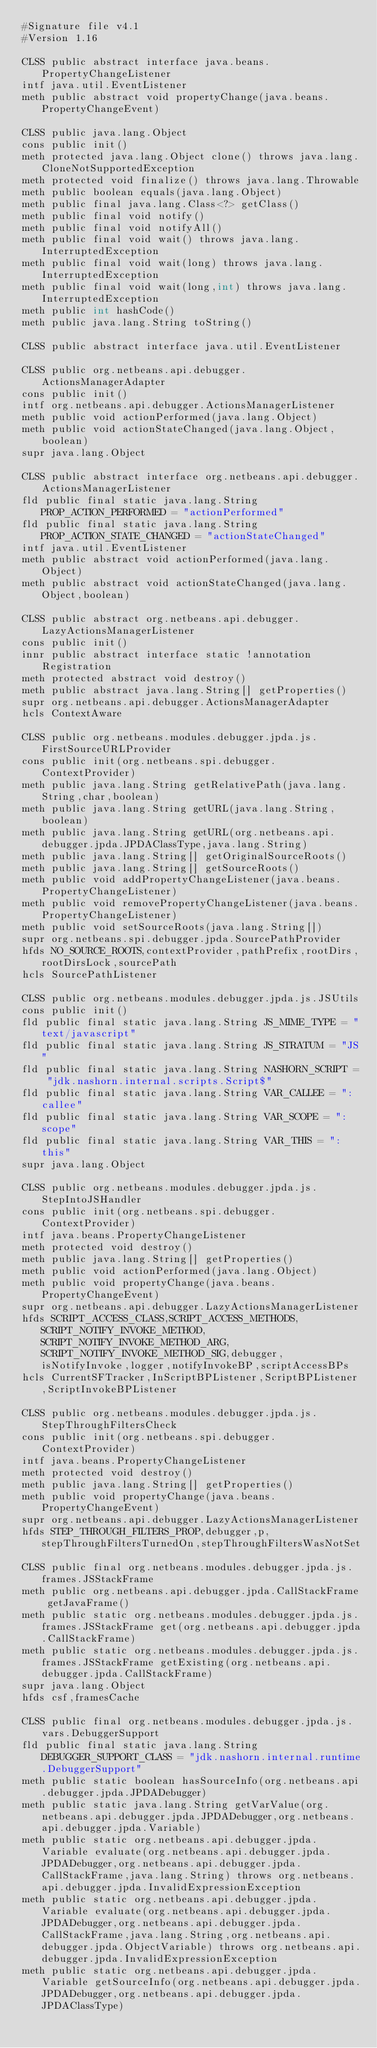<code> <loc_0><loc_0><loc_500><loc_500><_SML_>#Signature file v4.1
#Version 1.16

CLSS public abstract interface java.beans.PropertyChangeListener
intf java.util.EventListener
meth public abstract void propertyChange(java.beans.PropertyChangeEvent)

CLSS public java.lang.Object
cons public init()
meth protected java.lang.Object clone() throws java.lang.CloneNotSupportedException
meth protected void finalize() throws java.lang.Throwable
meth public boolean equals(java.lang.Object)
meth public final java.lang.Class<?> getClass()
meth public final void notify()
meth public final void notifyAll()
meth public final void wait() throws java.lang.InterruptedException
meth public final void wait(long) throws java.lang.InterruptedException
meth public final void wait(long,int) throws java.lang.InterruptedException
meth public int hashCode()
meth public java.lang.String toString()

CLSS public abstract interface java.util.EventListener

CLSS public org.netbeans.api.debugger.ActionsManagerAdapter
cons public init()
intf org.netbeans.api.debugger.ActionsManagerListener
meth public void actionPerformed(java.lang.Object)
meth public void actionStateChanged(java.lang.Object,boolean)
supr java.lang.Object

CLSS public abstract interface org.netbeans.api.debugger.ActionsManagerListener
fld public final static java.lang.String PROP_ACTION_PERFORMED = "actionPerformed"
fld public final static java.lang.String PROP_ACTION_STATE_CHANGED = "actionStateChanged"
intf java.util.EventListener
meth public abstract void actionPerformed(java.lang.Object)
meth public abstract void actionStateChanged(java.lang.Object,boolean)

CLSS public abstract org.netbeans.api.debugger.LazyActionsManagerListener
cons public init()
innr public abstract interface static !annotation Registration
meth protected abstract void destroy()
meth public abstract java.lang.String[] getProperties()
supr org.netbeans.api.debugger.ActionsManagerAdapter
hcls ContextAware

CLSS public org.netbeans.modules.debugger.jpda.js.FirstSourceURLProvider
cons public init(org.netbeans.spi.debugger.ContextProvider)
meth public java.lang.String getRelativePath(java.lang.String,char,boolean)
meth public java.lang.String getURL(java.lang.String,boolean)
meth public java.lang.String getURL(org.netbeans.api.debugger.jpda.JPDAClassType,java.lang.String)
meth public java.lang.String[] getOriginalSourceRoots()
meth public java.lang.String[] getSourceRoots()
meth public void addPropertyChangeListener(java.beans.PropertyChangeListener)
meth public void removePropertyChangeListener(java.beans.PropertyChangeListener)
meth public void setSourceRoots(java.lang.String[])
supr org.netbeans.spi.debugger.jpda.SourcePathProvider
hfds NO_SOURCE_ROOTS,contextProvider,pathPrefix,rootDirs,rootDirsLock,sourcePath
hcls SourcePathListener

CLSS public org.netbeans.modules.debugger.jpda.js.JSUtils
cons public init()
fld public final static java.lang.String JS_MIME_TYPE = "text/javascript"
fld public final static java.lang.String JS_STRATUM = "JS"
fld public final static java.lang.String NASHORN_SCRIPT = "jdk.nashorn.internal.scripts.Script$"
fld public final static java.lang.String VAR_CALLEE = ":callee"
fld public final static java.lang.String VAR_SCOPE = ":scope"
fld public final static java.lang.String VAR_THIS = ":this"
supr java.lang.Object

CLSS public org.netbeans.modules.debugger.jpda.js.StepIntoJSHandler
cons public init(org.netbeans.spi.debugger.ContextProvider)
intf java.beans.PropertyChangeListener
meth protected void destroy()
meth public java.lang.String[] getProperties()
meth public void actionPerformed(java.lang.Object)
meth public void propertyChange(java.beans.PropertyChangeEvent)
supr org.netbeans.api.debugger.LazyActionsManagerListener
hfds SCRIPT_ACCESS_CLASS,SCRIPT_ACCESS_METHODS,SCRIPT_NOTIFY_INVOKE_METHOD,SCRIPT_NOTIFY_INVOKE_METHOD_ARG,SCRIPT_NOTIFY_INVOKE_METHOD_SIG,debugger,isNotifyInvoke,logger,notifyInvokeBP,scriptAccessBPs
hcls CurrentSFTracker,InScriptBPListener,ScriptBPListener,ScriptInvokeBPListener

CLSS public org.netbeans.modules.debugger.jpda.js.StepThroughFiltersCheck
cons public init(org.netbeans.spi.debugger.ContextProvider)
intf java.beans.PropertyChangeListener
meth protected void destroy()
meth public java.lang.String[] getProperties()
meth public void propertyChange(java.beans.PropertyChangeEvent)
supr org.netbeans.api.debugger.LazyActionsManagerListener
hfds STEP_THROUGH_FILTERS_PROP,debugger,p,stepThroughFiltersTurnedOn,stepThroughFiltersWasNotSet

CLSS public final org.netbeans.modules.debugger.jpda.js.frames.JSStackFrame
meth public org.netbeans.api.debugger.jpda.CallStackFrame getJavaFrame()
meth public static org.netbeans.modules.debugger.jpda.js.frames.JSStackFrame get(org.netbeans.api.debugger.jpda.CallStackFrame)
meth public static org.netbeans.modules.debugger.jpda.js.frames.JSStackFrame getExisting(org.netbeans.api.debugger.jpda.CallStackFrame)
supr java.lang.Object
hfds csf,framesCache

CLSS public final org.netbeans.modules.debugger.jpda.js.vars.DebuggerSupport
fld public final static java.lang.String DEBUGGER_SUPPORT_CLASS = "jdk.nashorn.internal.runtime.DebuggerSupport"
meth public static boolean hasSourceInfo(org.netbeans.api.debugger.jpda.JPDADebugger)
meth public static java.lang.String getVarValue(org.netbeans.api.debugger.jpda.JPDADebugger,org.netbeans.api.debugger.jpda.Variable)
meth public static org.netbeans.api.debugger.jpda.Variable evaluate(org.netbeans.api.debugger.jpda.JPDADebugger,org.netbeans.api.debugger.jpda.CallStackFrame,java.lang.String) throws org.netbeans.api.debugger.jpda.InvalidExpressionException
meth public static org.netbeans.api.debugger.jpda.Variable evaluate(org.netbeans.api.debugger.jpda.JPDADebugger,org.netbeans.api.debugger.jpda.CallStackFrame,java.lang.String,org.netbeans.api.debugger.jpda.ObjectVariable) throws org.netbeans.api.debugger.jpda.InvalidExpressionException
meth public static org.netbeans.api.debugger.jpda.Variable getSourceInfo(org.netbeans.api.debugger.jpda.JPDADebugger,org.netbeans.api.debugger.jpda.JPDAClassType)</code> 